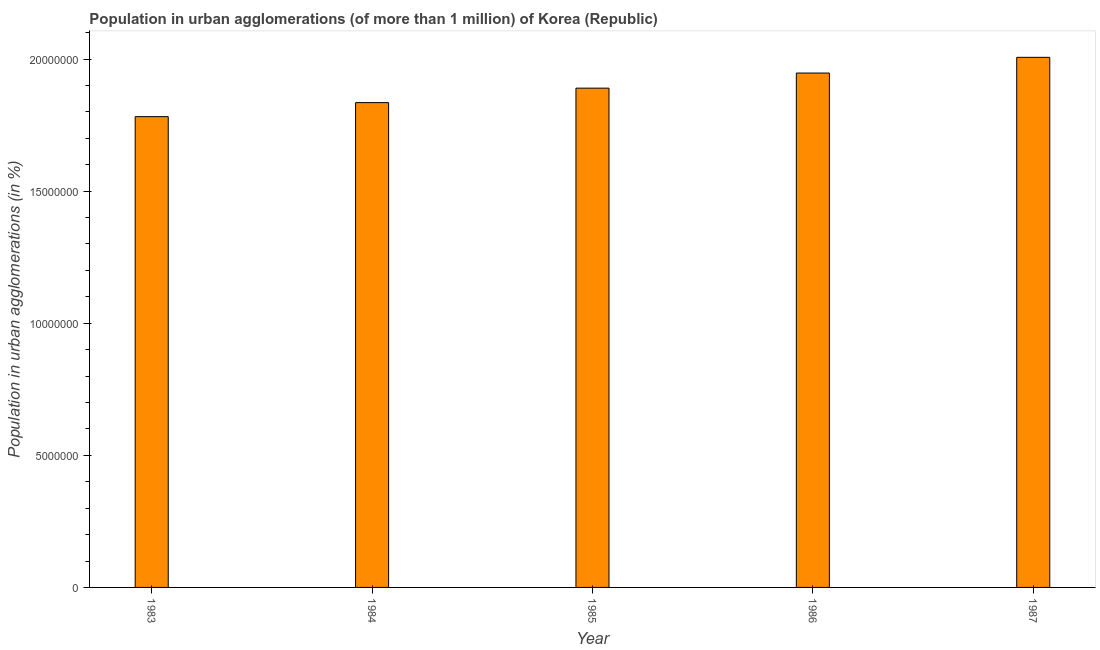What is the title of the graph?
Provide a short and direct response. Population in urban agglomerations (of more than 1 million) of Korea (Republic). What is the label or title of the Y-axis?
Your answer should be very brief. Population in urban agglomerations (in %). What is the population in urban agglomerations in 1987?
Your answer should be very brief. 2.01e+07. Across all years, what is the maximum population in urban agglomerations?
Ensure brevity in your answer.  2.01e+07. Across all years, what is the minimum population in urban agglomerations?
Your response must be concise. 1.78e+07. In which year was the population in urban agglomerations minimum?
Offer a terse response. 1983. What is the sum of the population in urban agglomerations?
Your answer should be very brief. 9.46e+07. What is the difference between the population in urban agglomerations in 1983 and 1986?
Ensure brevity in your answer.  -1.65e+06. What is the average population in urban agglomerations per year?
Keep it short and to the point. 1.89e+07. What is the median population in urban agglomerations?
Your answer should be compact. 1.89e+07. Do a majority of the years between 1987 and 1985 (inclusive) have population in urban agglomerations greater than 14000000 %?
Your answer should be compact. Yes. What is the ratio of the population in urban agglomerations in 1983 to that in 1987?
Provide a succinct answer. 0.89. Is the difference between the population in urban agglomerations in 1983 and 1986 greater than the difference between any two years?
Offer a terse response. No. What is the difference between the highest and the second highest population in urban agglomerations?
Your response must be concise. 5.95e+05. What is the difference between the highest and the lowest population in urban agglomerations?
Make the answer very short. 2.25e+06. Are all the bars in the graph horizontal?
Offer a very short reply. No. How many years are there in the graph?
Keep it short and to the point. 5. What is the difference between two consecutive major ticks on the Y-axis?
Ensure brevity in your answer.  5.00e+06. What is the Population in urban agglomerations (in %) of 1983?
Your answer should be very brief. 1.78e+07. What is the Population in urban agglomerations (in %) of 1984?
Keep it short and to the point. 1.84e+07. What is the Population in urban agglomerations (in %) in 1985?
Provide a short and direct response. 1.89e+07. What is the Population in urban agglomerations (in %) in 1986?
Offer a very short reply. 1.95e+07. What is the Population in urban agglomerations (in %) of 1987?
Keep it short and to the point. 2.01e+07. What is the difference between the Population in urban agglomerations (in %) in 1983 and 1984?
Offer a terse response. -5.31e+05. What is the difference between the Population in urban agglomerations (in %) in 1983 and 1985?
Ensure brevity in your answer.  -1.08e+06. What is the difference between the Population in urban agglomerations (in %) in 1983 and 1986?
Your answer should be compact. -1.65e+06. What is the difference between the Population in urban agglomerations (in %) in 1983 and 1987?
Your answer should be compact. -2.25e+06. What is the difference between the Population in urban agglomerations (in %) in 1984 and 1985?
Provide a short and direct response. -5.48e+05. What is the difference between the Population in urban agglomerations (in %) in 1984 and 1986?
Offer a very short reply. -1.12e+06. What is the difference between the Population in urban agglomerations (in %) in 1984 and 1987?
Your response must be concise. -1.71e+06. What is the difference between the Population in urban agglomerations (in %) in 1985 and 1986?
Your answer should be compact. -5.72e+05. What is the difference between the Population in urban agglomerations (in %) in 1985 and 1987?
Give a very brief answer. -1.17e+06. What is the difference between the Population in urban agglomerations (in %) in 1986 and 1987?
Provide a short and direct response. -5.95e+05. What is the ratio of the Population in urban agglomerations (in %) in 1983 to that in 1984?
Keep it short and to the point. 0.97. What is the ratio of the Population in urban agglomerations (in %) in 1983 to that in 1985?
Ensure brevity in your answer.  0.94. What is the ratio of the Population in urban agglomerations (in %) in 1983 to that in 1986?
Ensure brevity in your answer.  0.92. What is the ratio of the Population in urban agglomerations (in %) in 1983 to that in 1987?
Ensure brevity in your answer.  0.89. What is the ratio of the Population in urban agglomerations (in %) in 1984 to that in 1985?
Keep it short and to the point. 0.97. What is the ratio of the Population in urban agglomerations (in %) in 1984 to that in 1986?
Your answer should be very brief. 0.94. What is the ratio of the Population in urban agglomerations (in %) in 1984 to that in 1987?
Give a very brief answer. 0.92. What is the ratio of the Population in urban agglomerations (in %) in 1985 to that in 1987?
Make the answer very short. 0.94. 